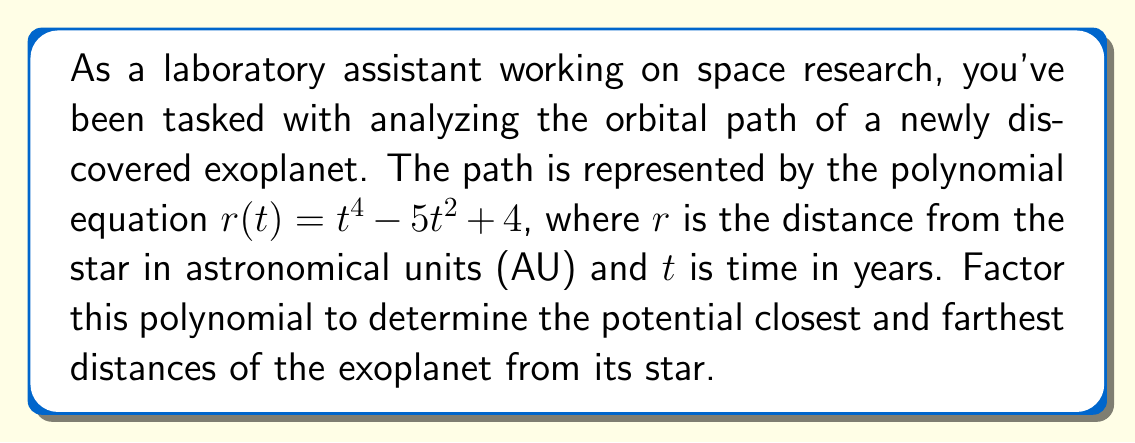Give your solution to this math problem. Let's approach this step-by-step:

1) First, we recognize that this is a fourth-degree polynomial in the form of $a^2 - b^2 = (a+b)(a-b)$.

2) We can rewrite the polynomial as:
   $$r(t) = (t^2)^2 - 5t^2 + 4$$

3) Now, we need to find two numbers that multiply to give 4 and add up to -5. These numbers are -1 and -4.

4) We can rewrite the polynomial as:
   $$r(t) = (t^2)^2 - t^2 - 4t^2 + 4$$

5) Grouping the terms:
   $$r(t) = ((t^2)^2 - t^2) + (-4t^2 + 4)$$

6) Factor out the common factors:
   $$r(t) = t^2(t^2 - 1) - 4(t^2 - 1)$$

7) Factor out $(t^2 - 1)$:
   $$r(t) = (t^2 - 1)(t^2 - 4)$$

8) Factor the remaining quadratic terms:
   $$r(t) = (t+1)(t-1)(t+2)(t-2)$$

This factored form tells us that the polynomial equals zero when $t = ±1$ or $t = ±2$. In the context of the orbital path, these are the times when the exoplanet is closest to or farthest from its star.

The closest distance occurs when $t = ±1$, giving $r(±1) = 0$ AU.
The farthest distance occurs when $t = ±2$, giving $r(±2) = 0$ AU.

However, since distance can't be negative, the actual orbit likely oscillates between 0 AU and some positive value, with 0 AU being the point where the exoplanet passes through its star (which is physically impossible). This suggests that the model has limitations and may need refinement.
Answer: $(t+1)(t-1)(t+2)(t-2)$ 